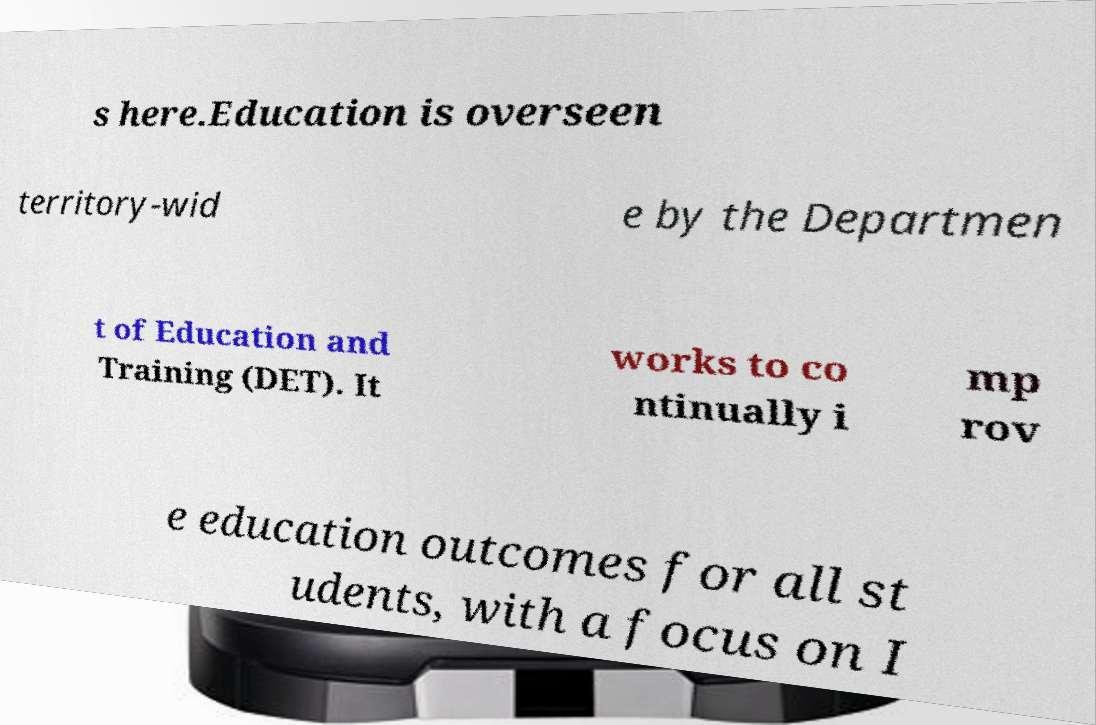Could you extract and type out the text from this image? s here.Education is overseen territory-wid e by the Departmen t of Education and Training (DET). It works to co ntinually i mp rov e education outcomes for all st udents, with a focus on I 